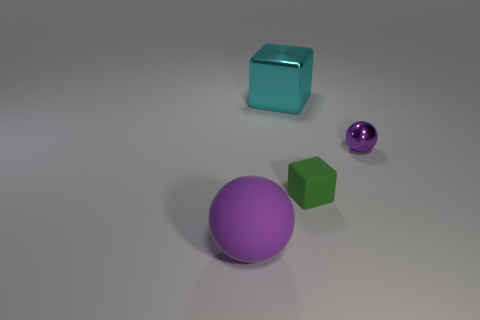How many purple objects are both in front of the small purple metallic object and behind the big purple thing?
Your response must be concise. 0. Does the small shiny ball have the same color as the large matte ball?
Keep it short and to the point. Yes. What is the material of the cyan thing that is the same shape as the small green matte thing?
Keep it short and to the point. Metal. Is the number of tiny purple things behind the small metallic sphere the same as the number of rubber objects that are right of the big metal block?
Your answer should be very brief. No. Do the tiny purple object and the tiny green block have the same material?
Provide a short and direct response. No. How many blue objects are either tiny matte blocks or large cubes?
Your answer should be compact. 0. What number of tiny objects have the same shape as the big cyan metallic thing?
Make the answer very short. 1. What is the large sphere made of?
Provide a succinct answer. Rubber. Are there the same number of big purple spheres on the left side of the cyan metal block and green cubes?
Provide a short and direct response. Yes. There is a purple object that is the same size as the cyan thing; what is its shape?
Your answer should be compact. Sphere. 